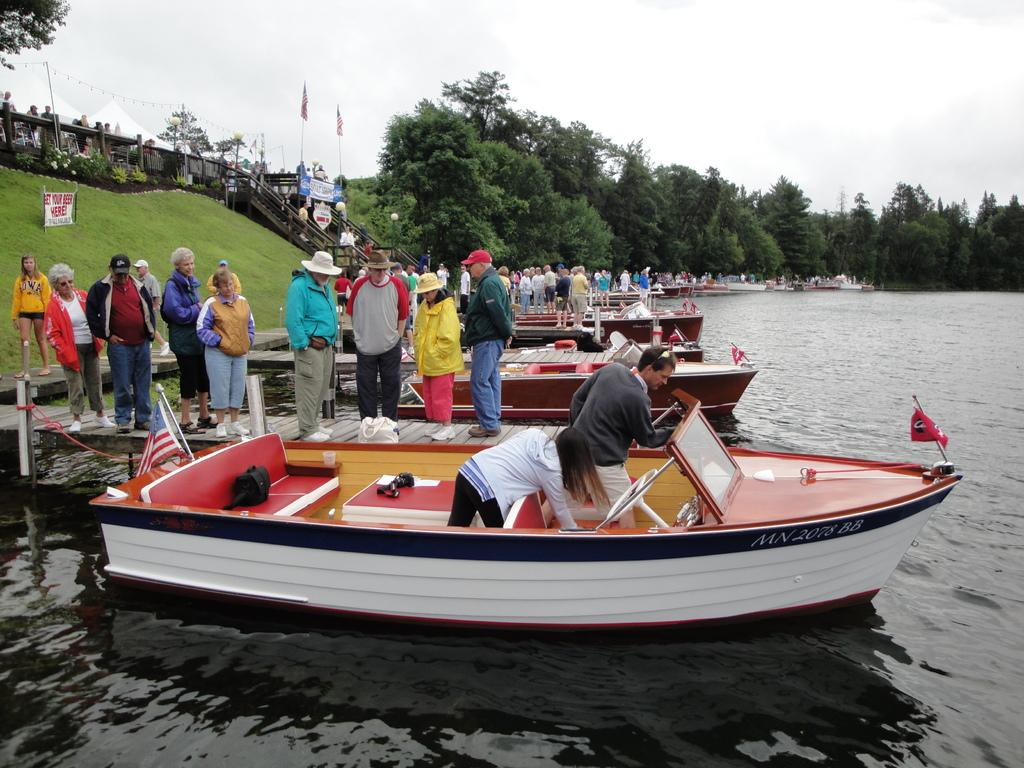<image>
Relay a brief, clear account of the picture shown. People standing on the dock with a Get Your Beer Here sign behind them. 